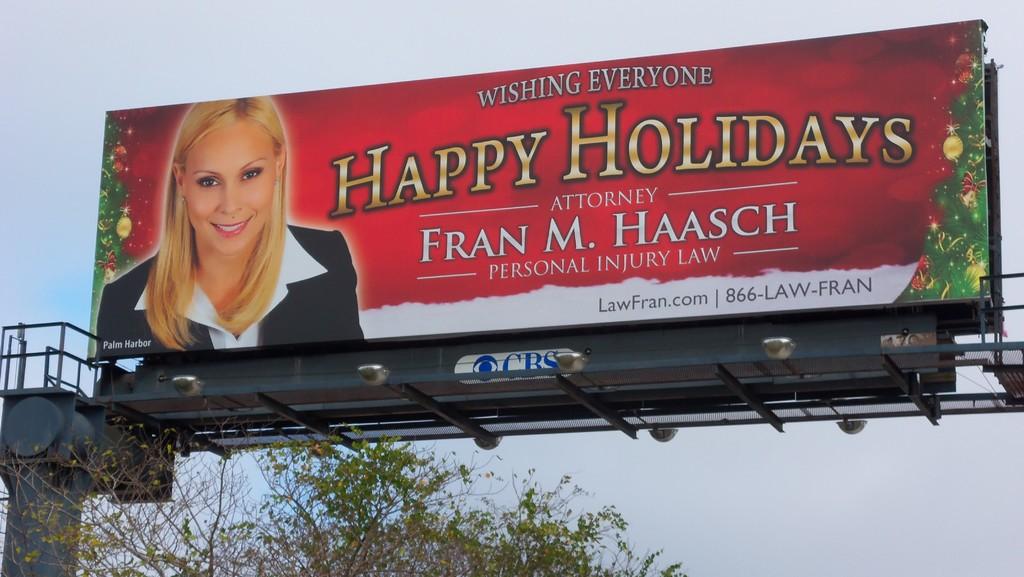What is the name of the attorney?
Your response must be concise. Fran m. haasch. 